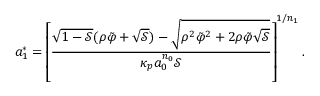Convert formula to latex. <formula><loc_0><loc_0><loc_500><loc_500>a _ { 1 } ^ { * } = \left [ \frac { \sqrt { 1 - \mathcal { S } } ( \rho \tilde { \varphi } + \sqrt { \mathcal { S } } ) - \sqrt { \rho ^ { 2 } \tilde { \varphi } ^ { 2 } + 2 \rho \tilde { \varphi } \sqrt { \mathcal { S } } } } { \kappa _ { p } a _ { 0 } ^ { n _ { 0 } } \mathcal { S } } \right ] ^ { 1 / n _ { 1 } } .</formula> 